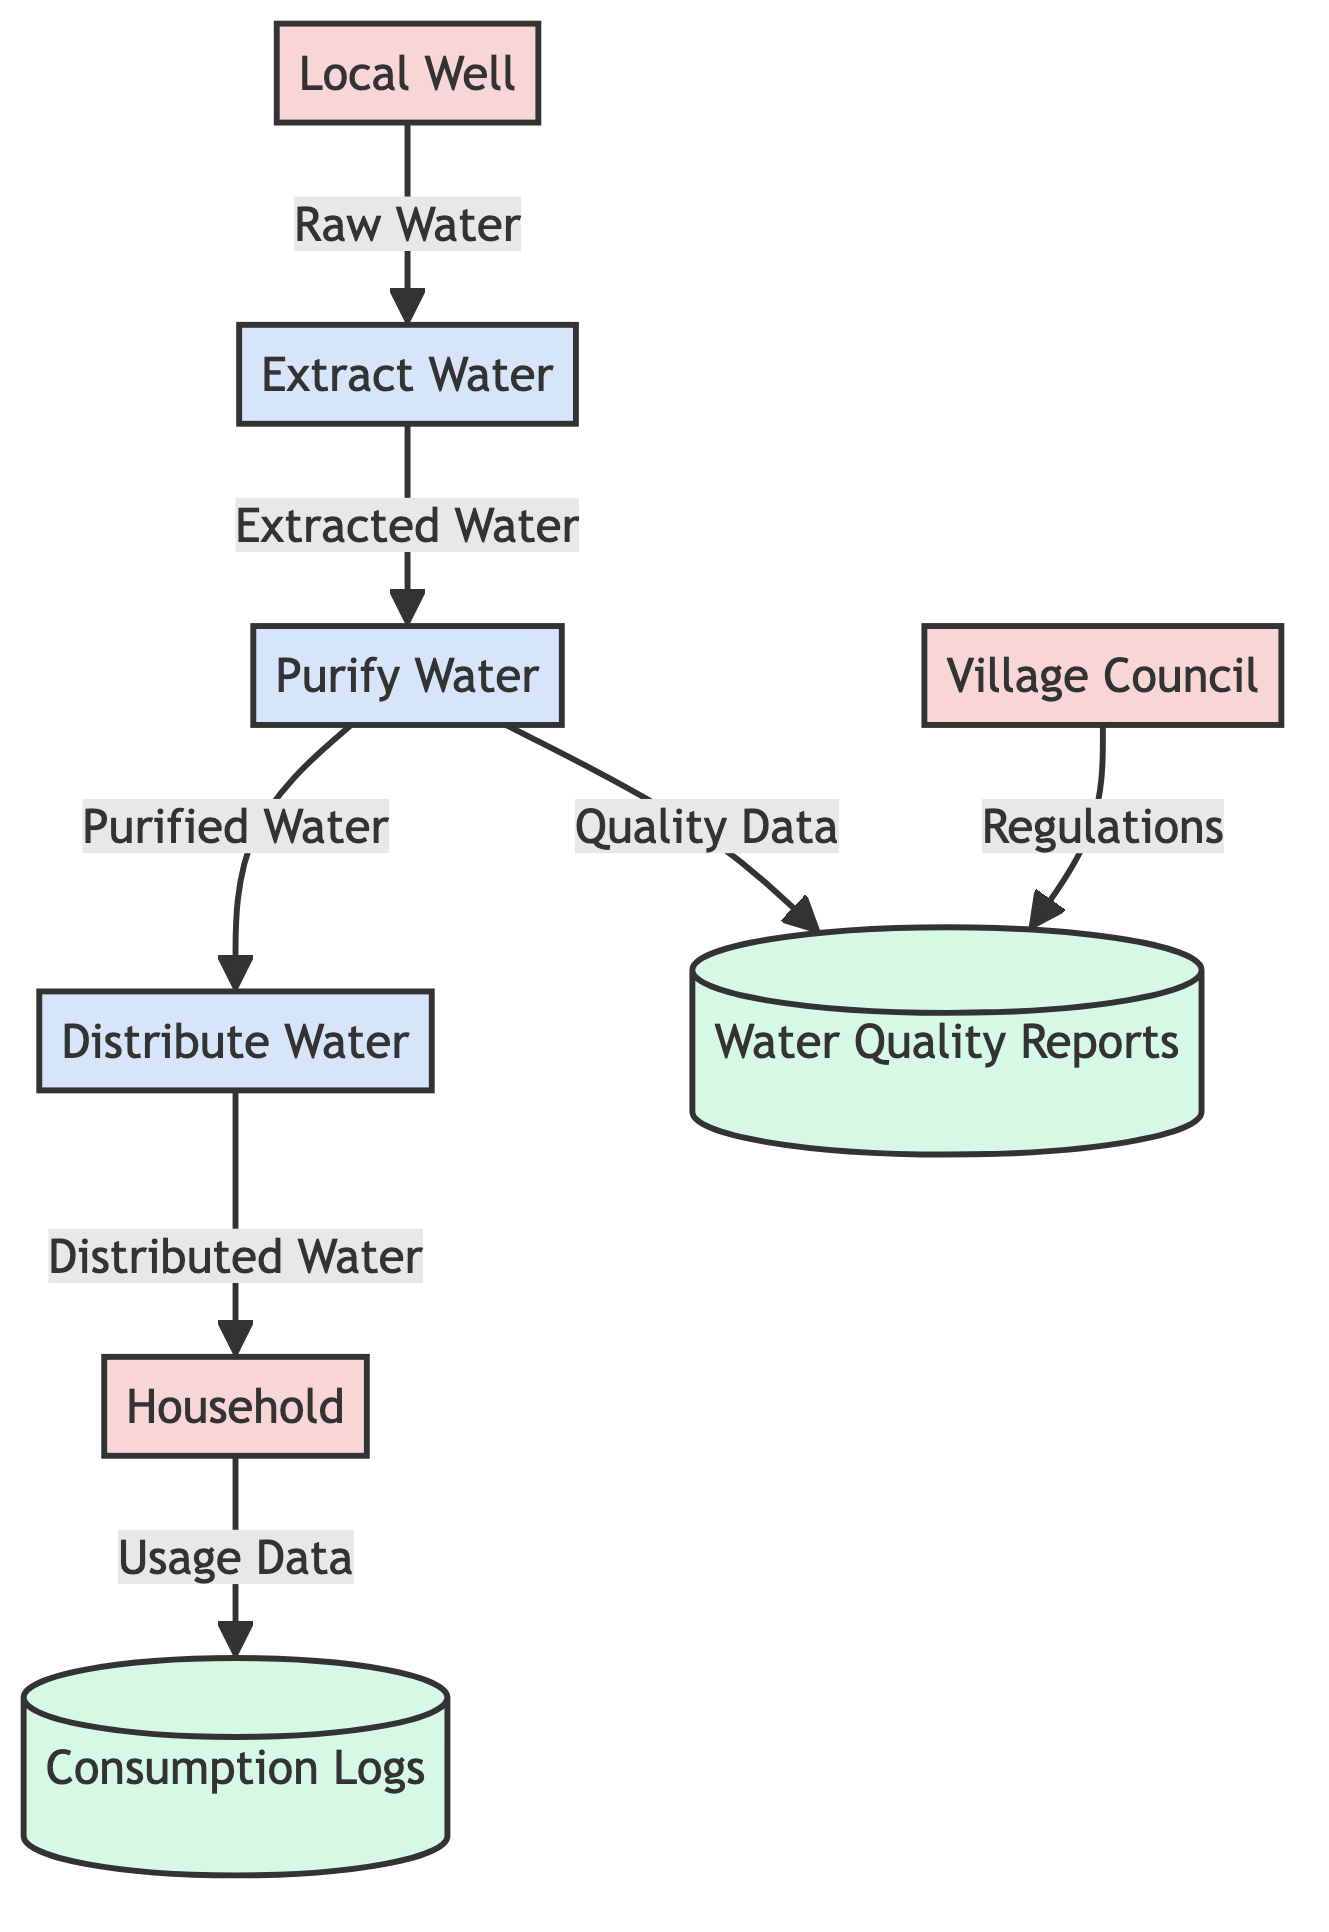What are the external entities in the diagram? The diagram lists three external entities: Local Well, Village Council, and Household. These are the nodes where data flows originate or end without processing.
Answer: Local Well, Village Council, Household How many processes are depicted in the diagram? There are three listed processes in the diagram: Extract Water, Purify Water, and Distribute Water. Counting these gives the total number of processes.
Answer: 3 What type of data flows from the Local Well to Extract Water? The data flow from the Local Well to Extract Water is labeled Raw Water, indicating the type of data being transferred.
Answer: Raw Water Which process sends data to the Water Quality Reports datastore? The Purify Water process sends Quality Data to the Water Quality Reports datastore, as indicated in the data flows.
Answer: Purify Water What is the relationship between the Household and Consumption Logs? The diagram shows that Household sends Usage Data to the Consumption Logs datastore, establishing a flow of data between these entities.
Answer: Usage Data How many data flows are involved in the water distribution process? The diagram contains six data flows related to the processes involved in the water distribution: Raw Water, Extracted Water, Purified Water, Distributed Water, Quality Data, and Usage Data. Counting these gives the total.
Answer: 6 What type of regulations are depicted in the data flow? The Village Council sends Regulations to the Water Quality Reports datastore. This indicates that this type of data flow involves regulatory information from the council.
Answer: Regulations Which process initiates the water extraction? The data flow specifies that the process Extract Water is initiated by the Local Well through the flow of Raw Water.
Answer: Extract Water 